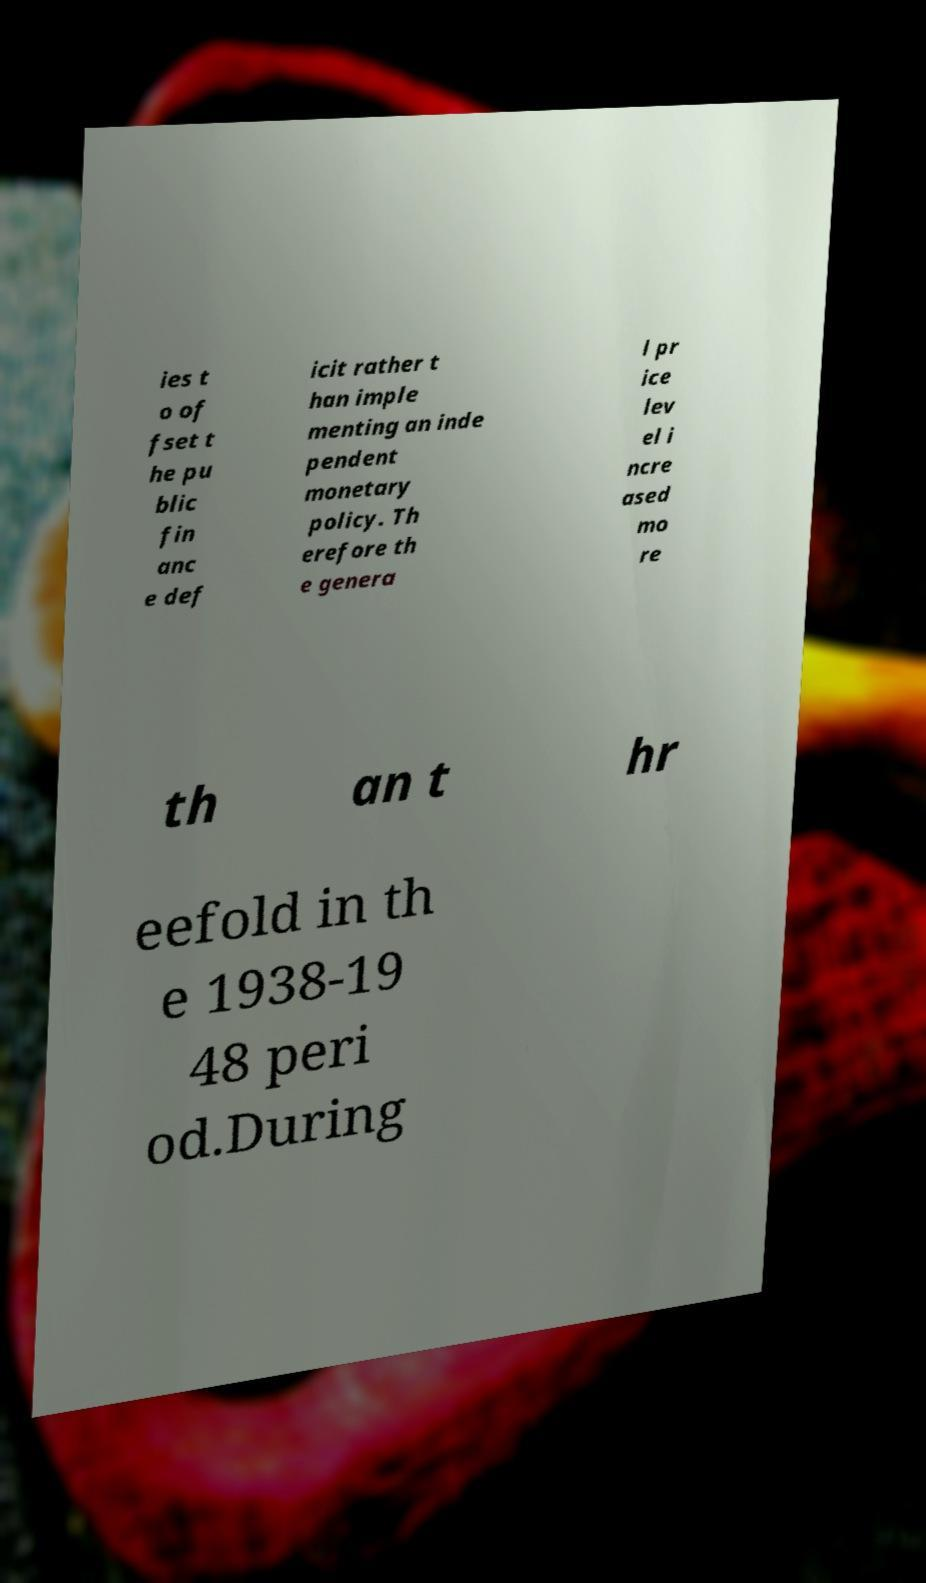There's text embedded in this image that I need extracted. Can you transcribe it verbatim? ies t o of fset t he pu blic fin anc e def icit rather t han imple menting an inde pendent monetary policy. Th erefore th e genera l pr ice lev el i ncre ased mo re th an t hr eefold in th e 1938-19 48 peri od.During 